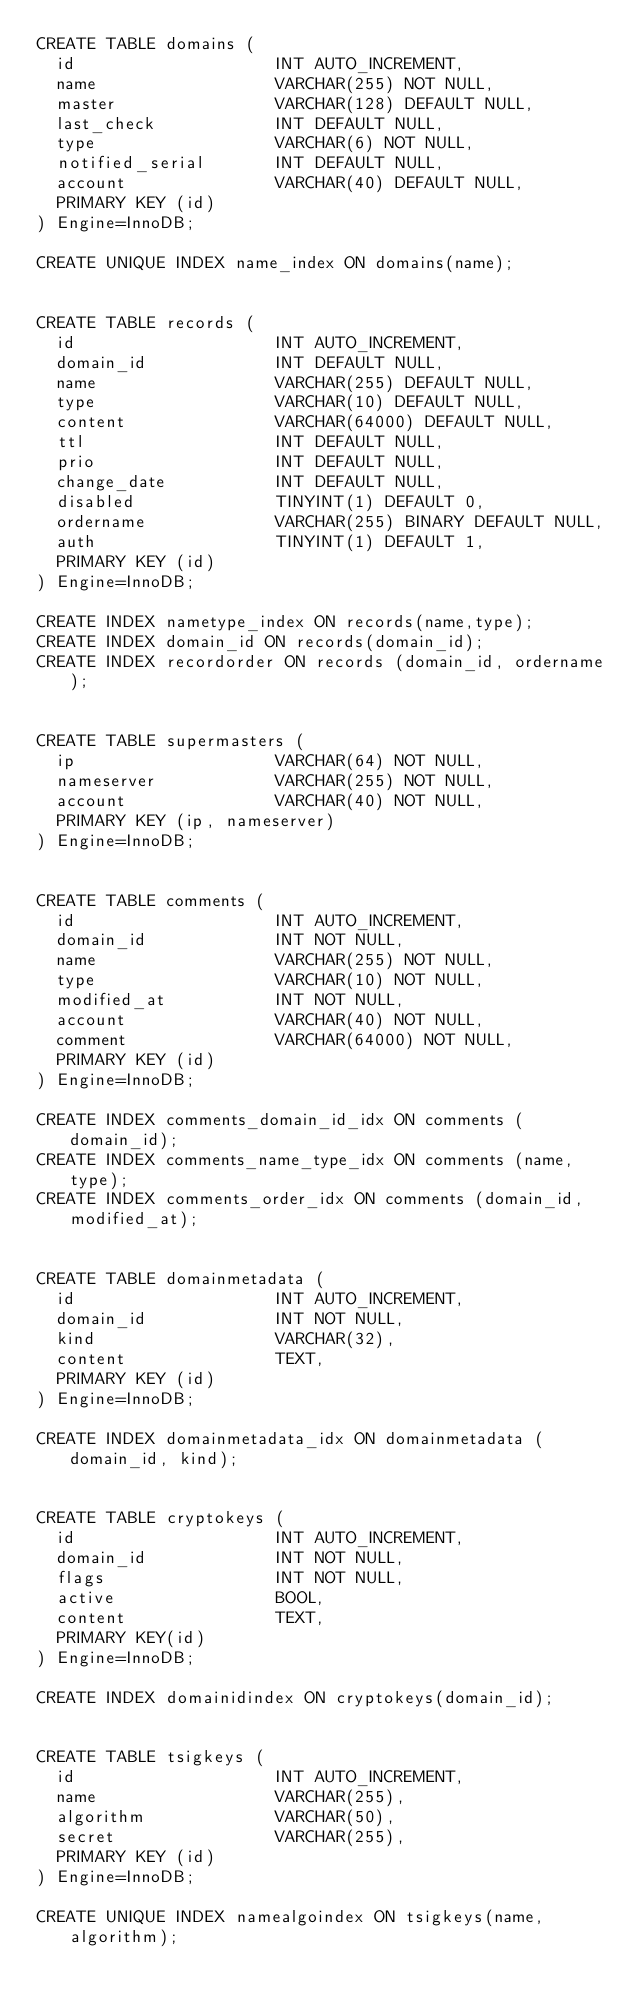Convert code to text. <code><loc_0><loc_0><loc_500><loc_500><_SQL_>CREATE TABLE domains (
  id                    INT AUTO_INCREMENT,
  name                  VARCHAR(255) NOT NULL,
  master                VARCHAR(128) DEFAULT NULL,
  last_check            INT DEFAULT NULL,
  type                  VARCHAR(6) NOT NULL,
  notified_serial       INT DEFAULT NULL,
  account               VARCHAR(40) DEFAULT NULL,
  PRIMARY KEY (id)
) Engine=InnoDB;

CREATE UNIQUE INDEX name_index ON domains(name);


CREATE TABLE records (
  id                    INT AUTO_INCREMENT,
  domain_id             INT DEFAULT NULL,
  name                  VARCHAR(255) DEFAULT NULL,
  type                  VARCHAR(10) DEFAULT NULL,
  content               VARCHAR(64000) DEFAULT NULL,
  ttl                   INT DEFAULT NULL,
  prio                  INT DEFAULT NULL,
  change_date           INT DEFAULT NULL,
  disabled              TINYINT(1) DEFAULT 0,
  ordername             VARCHAR(255) BINARY DEFAULT NULL,
  auth                  TINYINT(1) DEFAULT 1,
  PRIMARY KEY (id)
) Engine=InnoDB;

CREATE INDEX nametype_index ON records(name,type);
CREATE INDEX domain_id ON records(domain_id);
CREATE INDEX recordorder ON records (domain_id, ordername);


CREATE TABLE supermasters (
  ip                    VARCHAR(64) NOT NULL,
  nameserver            VARCHAR(255) NOT NULL,
  account               VARCHAR(40) NOT NULL,
  PRIMARY KEY (ip, nameserver)
) Engine=InnoDB;


CREATE TABLE comments (
  id                    INT AUTO_INCREMENT,
  domain_id             INT NOT NULL,
  name                  VARCHAR(255) NOT NULL,
  type                  VARCHAR(10) NOT NULL,
  modified_at           INT NOT NULL,
  account               VARCHAR(40) NOT NULL,
  comment               VARCHAR(64000) NOT NULL,
  PRIMARY KEY (id)
) Engine=InnoDB;

CREATE INDEX comments_domain_id_idx ON comments (domain_id);
CREATE INDEX comments_name_type_idx ON comments (name, type);
CREATE INDEX comments_order_idx ON comments (domain_id, modified_at);


CREATE TABLE domainmetadata (
  id                    INT AUTO_INCREMENT,
  domain_id             INT NOT NULL,
  kind                  VARCHAR(32),
  content               TEXT,
  PRIMARY KEY (id)
) Engine=InnoDB;

CREATE INDEX domainmetadata_idx ON domainmetadata (domain_id, kind);


CREATE TABLE cryptokeys (
  id                    INT AUTO_INCREMENT,
  domain_id             INT NOT NULL,
  flags                 INT NOT NULL,
  active                BOOL,
  content               TEXT,
  PRIMARY KEY(id)
) Engine=InnoDB;

CREATE INDEX domainidindex ON cryptokeys(domain_id);


CREATE TABLE tsigkeys (
  id                    INT AUTO_INCREMENT,
  name                  VARCHAR(255),
  algorithm             VARCHAR(50),
  secret                VARCHAR(255),
  PRIMARY KEY (id)
) Engine=InnoDB;

CREATE UNIQUE INDEX namealgoindex ON tsigkeys(name, algorithm);</code> 